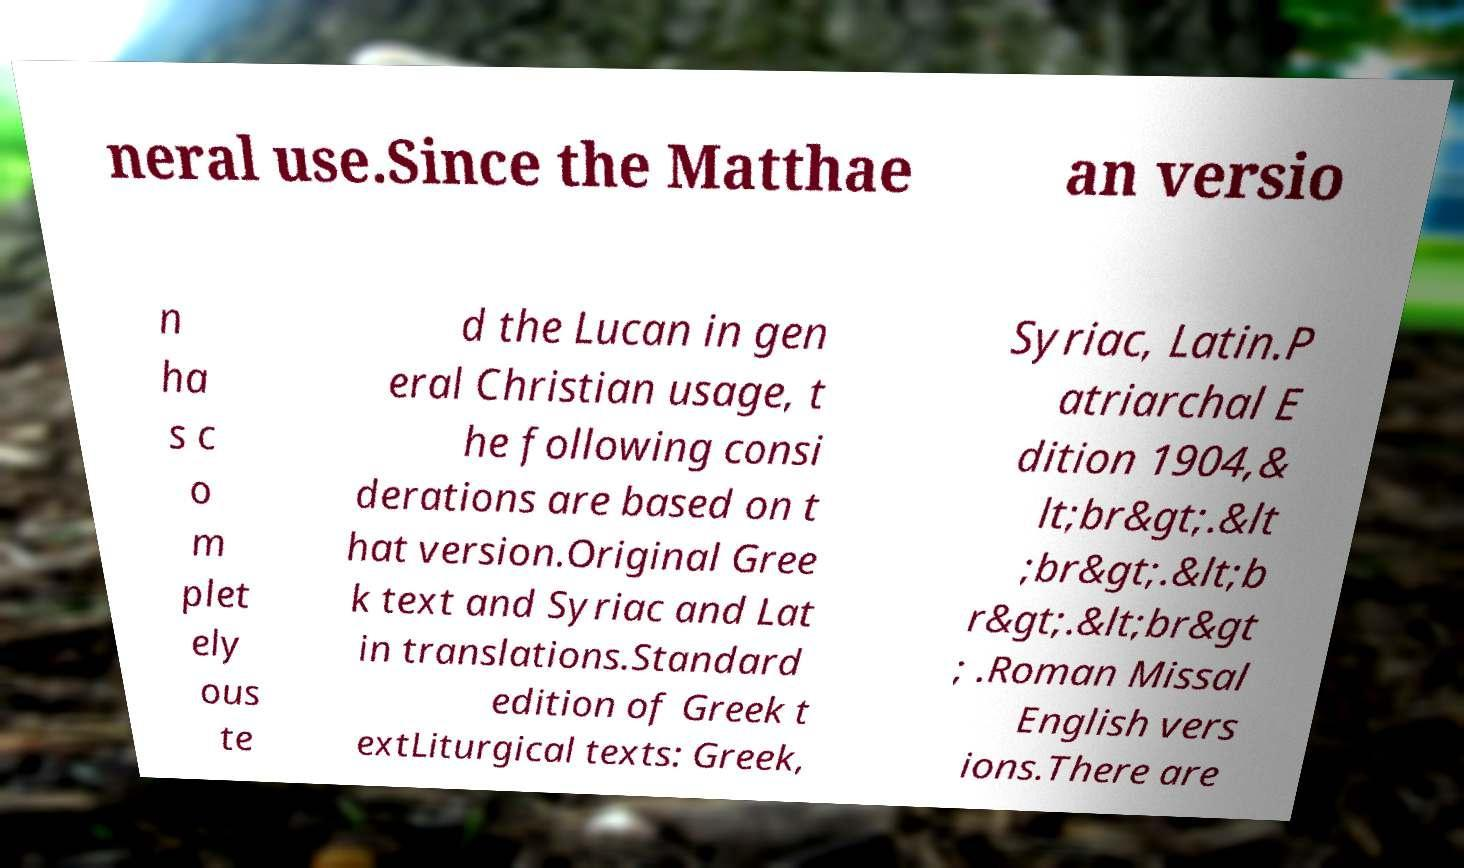I need the written content from this picture converted into text. Can you do that? neral use.Since the Matthae an versio n ha s c o m plet ely ous te d the Lucan in gen eral Christian usage, t he following consi derations are based on t hat version.Original Gree k text and Syriac and Lat in translations.Standard edition of Greek t extLiturgical texts: Greek, Syriac, Latin.P atriarchal E dition 1904,& lt;br&gt;.&lt ;br&gt;.&lt;b r&gt;.&lt;br&gt ; .Roman Missal English vers ions.There are 